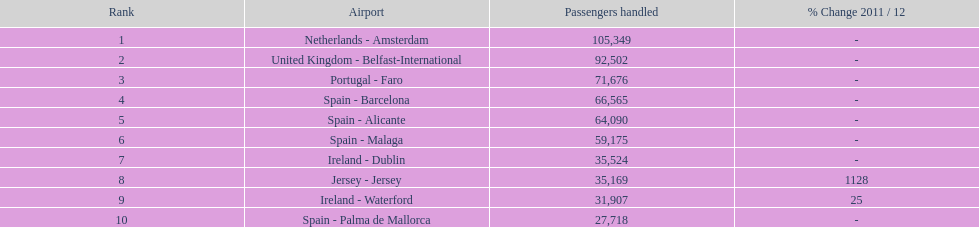Between the topped ranked airport, netherlands - amsterdam, & spain - palma de mallorca, what is the difference in the amount of passengers handled? 77,631. 